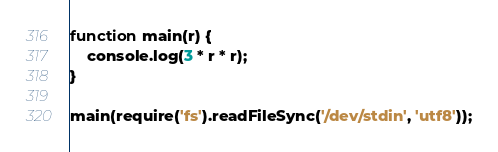<code> <loc_0><loc_0><loc_500><loc_500><_JavaScript_>function main(r) {
    console.log(3 * r * r);
}

main(require('fs').readFileSync('/dev/stdin', 'utf8'));</code> 